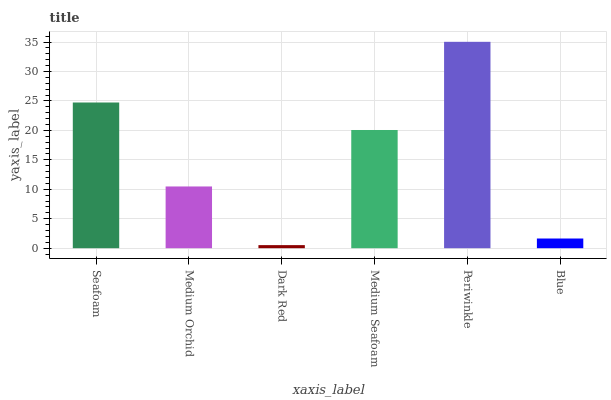Is Dark Red the minimum?
Answer yes or no. Yes. Is Periwinkle the maximum?
Answer yes or no. Yes. Is Medium Orchid the minimum?
Answer yes or no. No. Is Medium Orchid the maximum?
Answer yes or no. No. Is Seafoam greater than Medium Orchid?
Answer yes or no. Yes. Is Medium Orchid less than Seafoam?
Answer yes or no. Yes. Is Medium Orchid greater than Seafoam?
Answer yes or no. No. Is Seafoam less than Medium Orchid?
Answer yes or no. No. Is Medium Seafoam the high median?
Answer yes or no. Yes. Is Medium Orchid the low median?
Answer yes or no. Yes. Is Periwinkle the high median?
Answer yes or no. No. Is Medium Seafoam the low median?
Answer yes or no. No. 